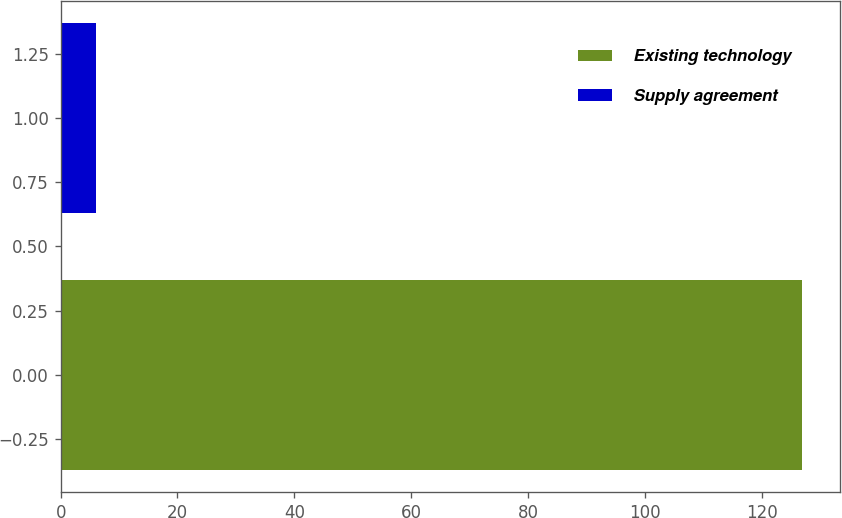Convert chart. <chart><loc_0><loc_0><loc_500><loc_500><bar_chart><fcel>Existing technology<fcel>Supply agreement<nl><fcel>127<fcel>6<nl></chart> 